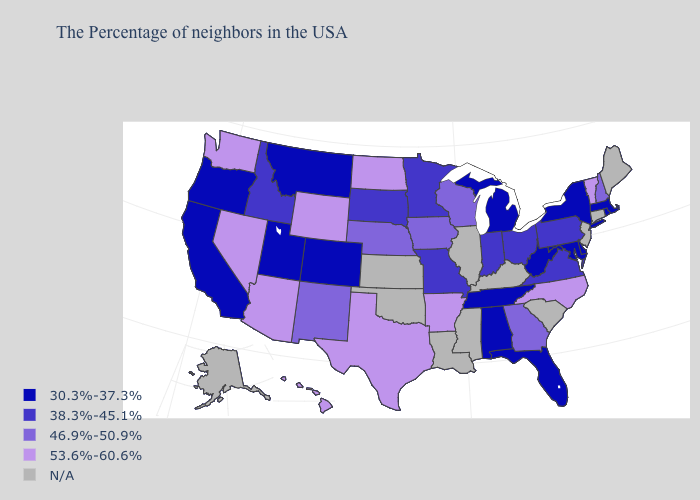Among the states that border Texas , which have the highest value?
Concise answer only. Arkansas. Among the states that border Missouri , does Tennessee have the lowest value?
Be succinct. Yes. What is the highest value in the USA?
Concise answer only. 53.6%-60.6%. Does Alabama have the lowest value in the South?
Short answer required. Yes. Which states hav the highest value in the South?
Answer briefly. North Carolina, Arkansas, Texas. Name the states that have a value in the range 30.3%-37.3%?
Concise answer only. Massachusetts, Rhode Island, New York, Delaware, Maryland, West Virginia, Florida, Michigan, Alabama, Tennessee, Colorado, Utah, Montana, California, Oregon. Does Colorado have the lowest value in the West?
Write a very short answer. Yes. Which states have the lowest value in the Northeast?
Answer briefly. Massachusetts, Rhode Island, New York. What is the value of New Mexico?
Keep it brief. 46.9%-50.9%. Does Washington have the lowest value in the USA?
Give a very brief answer. No. What is the value of Hawaii?
Answer briefly. 53.6%-60.6%. Which states hav the highest value in the Northeast?
Quick response, please. Vermont. Name the states that have a value in the range N/A?
Be succinct. Maine, Connecticut, New Jersey, South Carolina, Kentucky, Illinois, Mississippi, Louisiana, Kansas, Oklahoma, Alaska. 